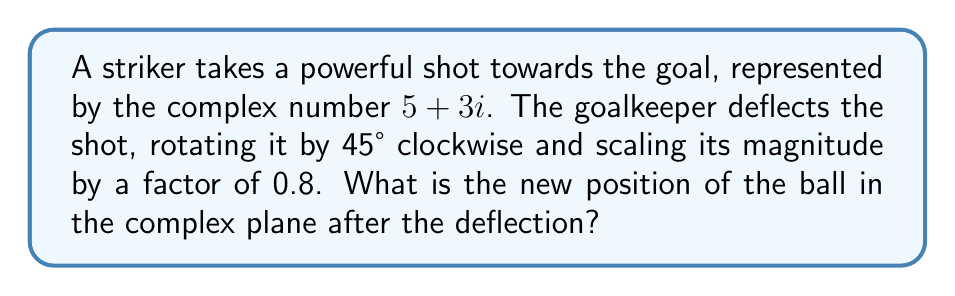Provide a solution to this math problem. Let's approach this step-by-step:

1) The initial position of the ball is $z = 5+3i$.

2) To rotate a complex number by θ clockwise, we multiply it by $e^{-iθ}$. In this case, θ = 45° = π/4 radians.

3) To scale the magnitude by 0.8, we multiply the result by 0.8.

4) Therefore, the transformation can be represented as:
   $z_{new} = 0.8 \cdot z \cdot e^{-i\pi/4}$

5) Let's calculate $e^{-i\pi/4}$:
   $e^{-i\pi/4} = \cos(-\pi/4) + i\sin(-\pi/4) = \frac{\sqrt{2}}{2} - i\frac{\sqrt{2}}{2}$

6) Now, let's multiply:
   $z_{new} = 0.8 \cdot (5+3i) \cdot (\frac{\sqrt{2}}{2} - i\frac{\sqrt{2}}{2})$

7) Distributing:
   $z_{new} = 0.8 \cdot ((5\frac{\sqrt{2}}{2} + 3\frac{\sqrt{2}}{2}) + (-5\frac{\sqrt{2}}{2} + 3\frac{\sqrt{2}}{2})i)$

8) Simplifying:
   $z_{new} = 0.8 \cdot (4\sqrt{2} - \sqrt{2}i)$
   $z_{new} = 3.2\sqrt{2} - 0.8\sqrt{2}i$

9) This can be approximated to:
   $z_{new} \approx 4.53 - 1.13i$
Answer: $3.2\sqrt{2} - 0.8\sqrt{2}i$ or approximately $4.53 - 1.13i$ 